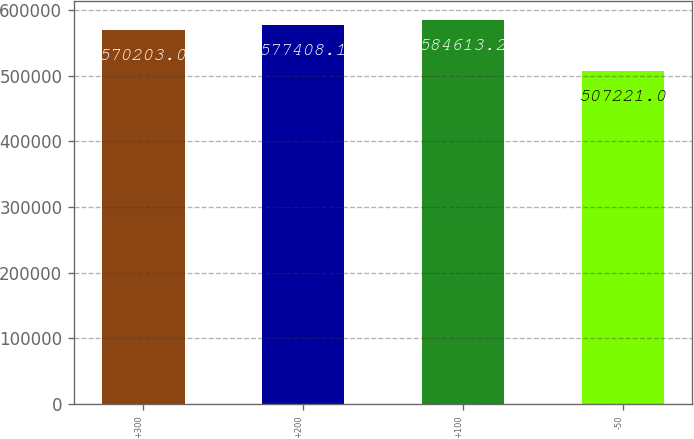<chart> <loc_0><loc_0><loc_500><loc_500><bar_chart><fcel>+300<fcel>+200<fcel>+100<fcel>-50<nl><fcel>570203<fcel>577408<fcel>584613<fcel>507221<nl></chart> 